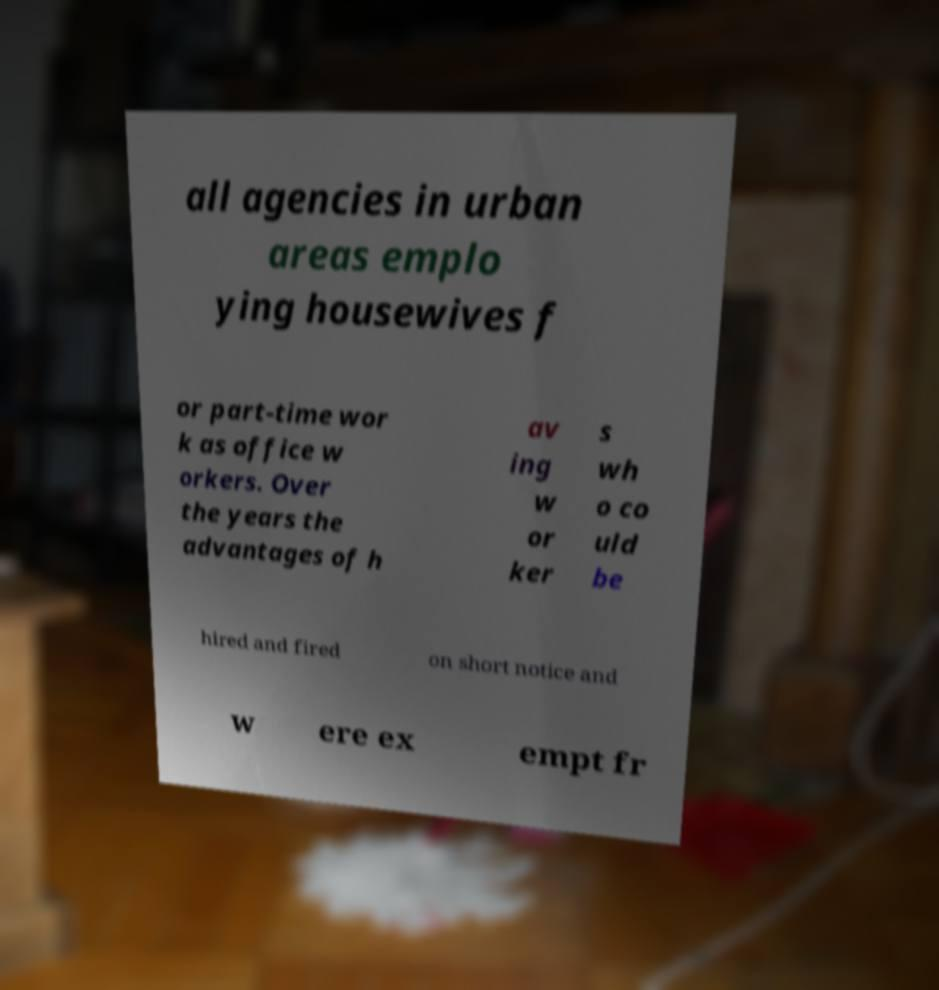Please identify and transcribe the text found in this image. all agencies in urban areas emplo ying housewives f or part-time wor k as office w orkers. Over the years the advantages of h av ing w or ker s wh o co uld be hired and fired on short notice and w ere ex empt fr 